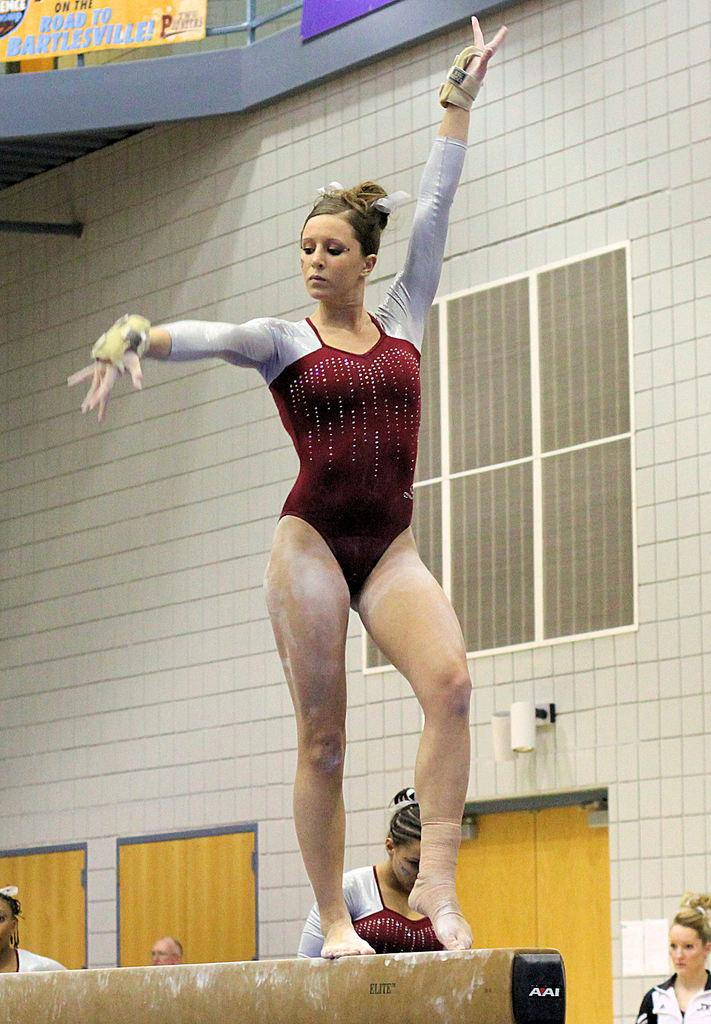What is the woman in the image doing? The woman is performing gymnastics in the image. Where is the woman performing gymnastics? The woman is on a wall. What can be seen in the background of the image? There are people standing, a wall with a window, and doors in the background of the image. What type of harmony can be heard in the image? There is no audible sound in the image, so it is not possible to determine if any harmony can be heard. 